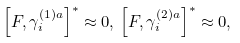<formula> <loc_0><loc_0><loc_500><loc_500>\left [ F , \gamma _ { i } ^ { ( 1 ) a } \right ] ^ { * } \approx 0 , \, \left [ F , \gamma _ { i } ^ { ( 2 ) a } \right ] ^ { * } \approx 0 ,</formula> 